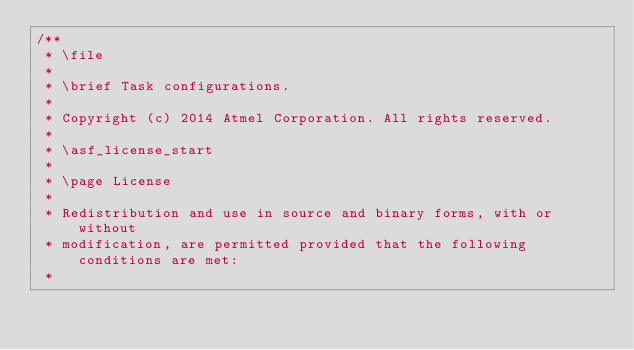Convert code to text. <code><loc_0><loc_0><loc_500><loc_500><_C_>/**
 * \file
 *
 * \brief Task configurations.
 *
 * Copyright (c) 2014 Atmel Corporation. All rights reserved.
 *
 * \asf_license_start
 *
 * \page License
 *
 * Redistribution and use in source and binary forms, with or without
 * modification, are permitted provided that the following conditions are met:
 *</code> 